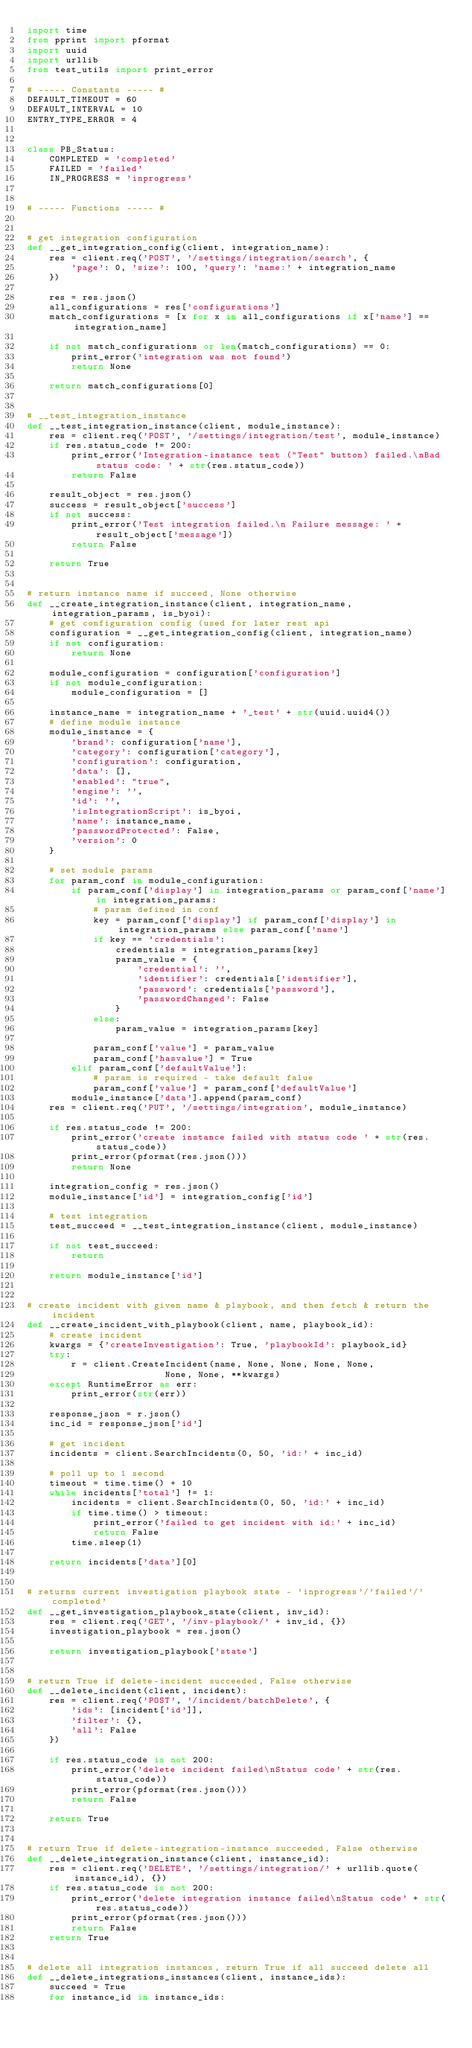Convert code to text. <code><loc_0><loc_0><loc_500><loc_500><_Python_>import time
from pprint import pformat
import uuid
import urllib
from test_utils import print_error

# ----- Constants ----- #
DEFAULT_TIMEOUT = 60
DEFAULT_INTERVAL = 10
ENTRY_TYPE_ERROR = 4


class PB_Status:
    COMPLETED = 'completed'
    FAILED = 'failed'
    IN_PROGRESS = 'inprogress'


# ----- Functions ----- #


# get integration configuration
def __get_integration_config(client, integration_name):
    res = client.req('POST', '/settings/integration/search', {
        'page': 0, 'size': 100, 'query': 'name:' + integration_name
    })

    res = res.json()
    all_configurations = res['configurations']
    match_configurations = [x for x in all_configurations if x['name'] == integration_name]

    if not match_configurations or len(match_configurations) == 0:
        print_error('integration was not found')
        return None

    return match_configurations[0]


# __test_integration_instance
def __test_integration_instance(client, module_instance):
    res = client.req('POST', '/settings/integration/test', module_instance)
    if res.status_code != 200:
        print_error('Integration-instance test ("Test" button) failed.\nBad status code: ' + str(res.status_code))
        return False

    result_object = res.json()
    success = result_object['success']
    if not success:
        print_error('Test integration failed.\n Failure message: ' + result_object['message'])
        return False

    return True


# return instance name if succeed, None otherwise
def __create_integration_instance(client, integration_name, integration_params, is_byoi):
    # get configuration config (used for later rest api
    configuration = __get_integration_config(client, integration_name)
    if not configuration:
        return None

    module_configuration = configuration['configuration']
    if not module_configuration:
        module_configuration = []

    instance_name = integration_name + '_test' + str(uuid.uuid4())
    # define module instance
    module_instance = {
        'brand': configuration['name'],
        'category': configuration['category'],
        'configuration': configuration,
        'data': [],
        'enabled': "true",
        'engine': '',
        'id': '',
        'isIntegrationScript': is_byoi,
        'name': instance_name,
        'passwordProtected': False,
        'version': 0
    }

    # set module params
    for param_conf in module_configuration:
        if param_conf['display'] in integration_params or param_conf['name'] in integration_params:
            # param defined in conf
            key = param_conf['display'] if param_conf['display'] in integration_params else param_conf['name']
            if key == 'credentials':
                credentials = integration_params[key]
                param_value = {
                    'credential': '',
                    'identifier': credentials['identifier'],
                    'password': credentials['password'],
                    'passwordChanged': False
                }
            else:
                param_value = integration_params[key]

            param_conf['value'] = param_value
            param_conf['hasvalue'] = True
        elif param_conf['defaultValue']:
            # param is required - take default falue
            param_conf['value'] = param_conf['defaultValue']
        module_instance['data'].append(param_conf)
    res = client.req('PUT', '/settings/integration', module_instance)

    if res.status_code != 200:
        print_error('create instance failed with status code ' + str(res.status_code))
        print_error(pformat(res.json()))
        return None

    integration_config = res.json()
    module_instance['id'] = integration_config['id']

    # test integration
    test_succeed = __test_integration_instance(client, module_instance)

    if not test_succeed:
        return

    return module_instance['id']


# create incident with given name & playbook, and then fetch & return the incident
def __create_incident_with_playbook(client, name, playbook_id):
    # create incident
    kwargs = {'createInvestigation': True, 'playbookId': playbook_id}
    try:
        r = client.CreateIncident(name, None, None, None, None,
                         None, None, **kwargs)
    except RuntimeError as err:
        print_error(str(err))

    response_json = r.json()
    inc_id = response_json['id']

    # get incident
    incidents = client.SearchIncidents(0, 50, 'id:' + inc_id)

    # poll up to 1 second
    timeout = time.time() + 10
    while incidents['total'] != 1:
        incidents = client.SearchIncidents(0, 50, 'id:' + inc_id)
        if time.time() > timeout:
            print_error('failed to get incident with id:' + inc_id)
            return False
        time.sleep(1)

    return incidents['data'][0]


# returns current investigation playbook state - 'inprogress'/'failed'/'completed'
def __get_investigation_playbook_state(client, inv_id):
    res = client.req('GET', '/inv-playbook/' + inv_id, {})
    investigation_playbook = res.json()

    return investigation_playbook['state']


# return True if delete-incident succeeded, False otherwise
def __delete_incident(client, incident):
    res = client.req('POST', '/incident/batchDelete', {
        'ids': [incident['id']],
        'filter': {},
        'all': False
    })

    if res.status_code is not 200:
        print_error('delete incident failed\nStatus code' + str(res.status_code))
        print_error(pformat(res.json()))
        return False

    return True


# return True if delete-integration-instance succeeded, False otherwise
def __delete_integration_instance(client, instance_id):
    res = client.req('DELETE', '/settings/integration/' + urllib.quote(instance_id), {})
    if res.status_code is not 200:
        print_error('delete integration instance failed\nStatus code' + str(res.status_code))
        print_error(pformat(res.json()))
        return False
    return True


# delete all integration instances, return True if all succeed delete all
def __delete_integrations_instances(client, instance_ids):
    succeed = True
    for instance_id in instance_ids:</code> 